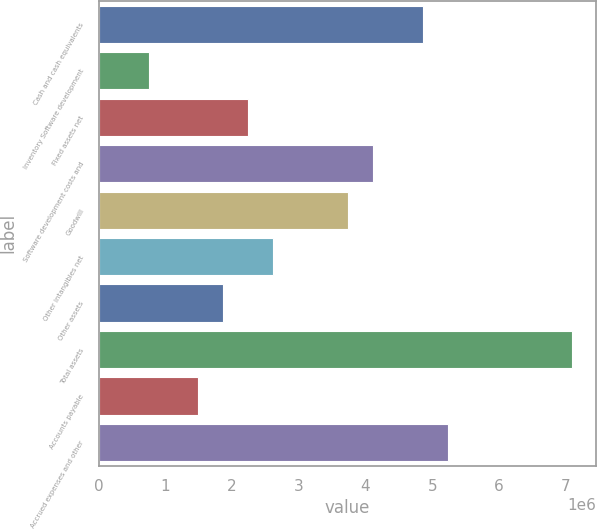Convert chart. <chart><loc_0><loc_0><loc_500><loc_500><bar_chart><fcel>Cash and cash equivalents<fcel>Inventory Software development<fcel>Fixed assets net<fcel>Software development costs and<fcel>Goodwill<fcel>Other intangibles net<fcel>Other assets<fcel>Total assets<fcel>Accounts payable<fcel>Accrued expenses and other<nl><fcel>4.8588e+06<fcel>748630<fcel>2.24324e+06<fcel>4.11149e+06<fcel>3.73784e+06<fcel>2.61689e+06<fcel>1.86958e+06<fcel>7.1007e+06<fcel>1.49593e+06<fcel>5.23245e+06<nl></chart> 